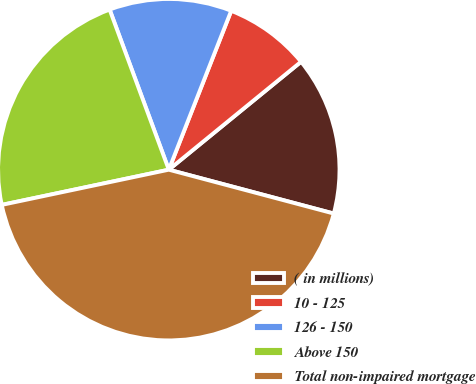Convert chart. <chart><loc_0><loc_0><loc_500><loc_500><pie_chart><fcel>( in millions)<fcel>10 - 125<fcel>126 - 150<fcel>Above 150<fcel>Total non-impaired mortgage<nl><fcel>15.03%<fcel>8.15%<fcel>11.59%<fcel>22.67%<fcel>42.56%<nl></chart> 